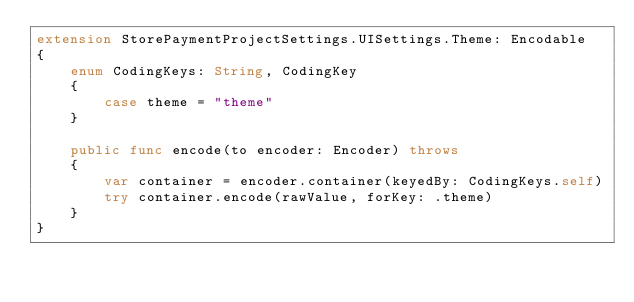<code> <loc_0><loc_0><loc_500><loc_500><_Swift_>extension StorePaymentProjectSettings.UISettings.Theme: Encodable
{
    enum CodingKeys: String, CodingKey
    {
        case theme = "theme"
    }

    public func encode(to encoder: Encoder) throws
    {
        var container = encoder.container(keyedBy: CodingKeys.self)
        try container.encode(rawValue, forKey: .theme)
    }
}
</code> 